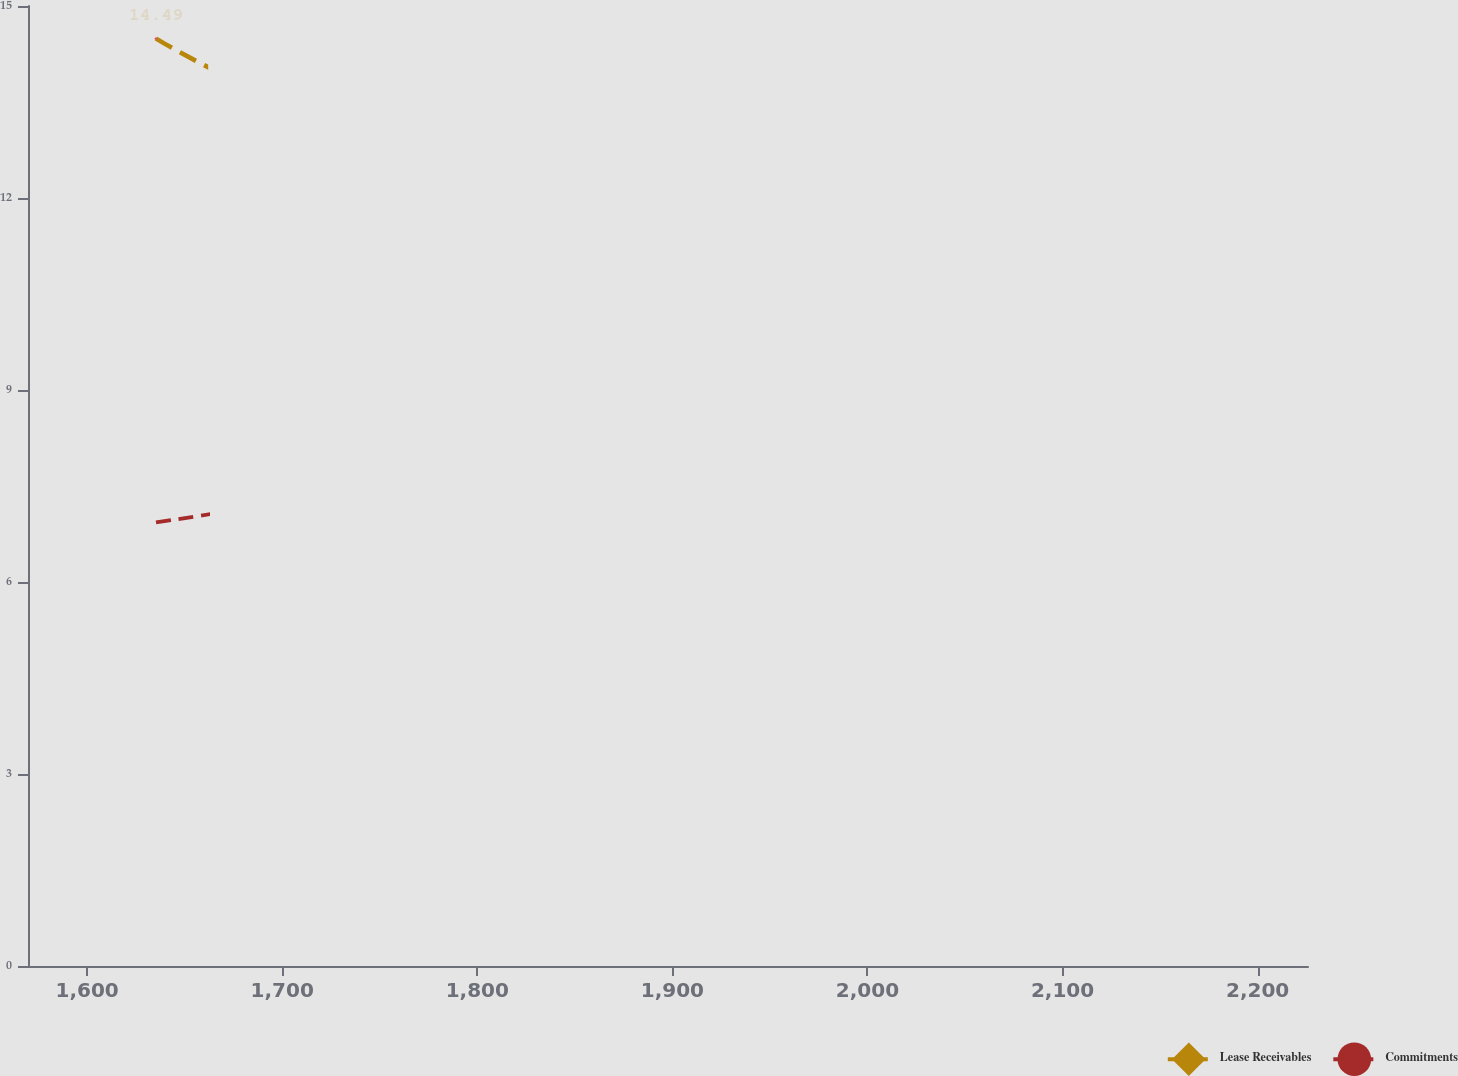Convert chart. <chart><loc_0><loc_0><loc_500><loc_500><line_chart><ecel><fcel>Lease Receivables<fcel>Commitments<nl><fcel>1635.29<fcel>14.49<fcel>6.93<nl><fcel>1811.96<fcel>12.38<fcel>7.78<nl><fcel>1913.1<fcel>12.1<fcel>8.31<nl><fcel>2165.04<fcel>13.72<fcel>7.15<nl><fcel>2291.45<fcel>14.95<fcel>6.1<nl></chart> 